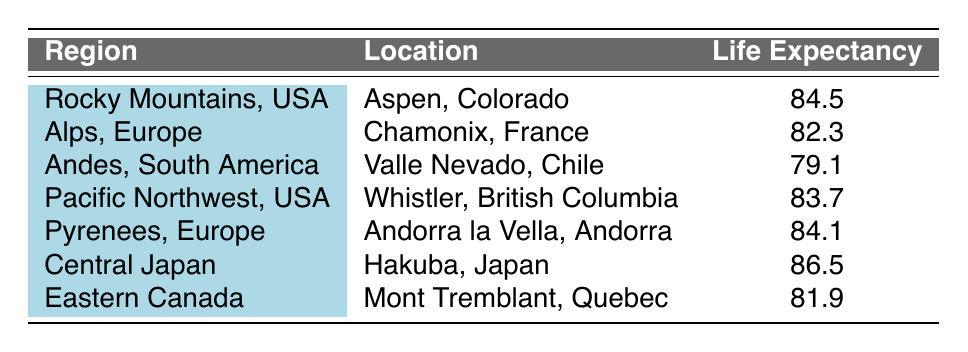What is the life expectancy in the Rocky Mountains, USA? Referring directly to the table, the life expectancy for the region "Rocky Mountains, USA," which is identified specifically with the location "Aspen, Colorado," is 84.5 years.
Answer: 84.5 Which location has the highest average life expectancy? Looking through the table, "Hakuba, Japan" under the region "Central Japan" has the highest value of average life expectancy at 86.5 years compared to all other listed locations.
Answer: Hakuba, Japan (86.5) What is the average life expectancy of locations in the Alps, Europe, and the Pyrenees, Europe combined? The average life expectancy for the Alps (Chamonix, France) is 82.3 and for the Pyrenees (Andorra la Vella, Andorra) is 84.1. To find the combined average, we sum these two values (82.3 + 84.1 = 166.4) and then divide by 2. Therefore, 166.4 / 2 = 83.2.
Answer: 83.2 Is the life expectancy in Valle Nevado, Chile higher than that in Mont Tremblant, Quebec? The life expectancy in Valle Nevado, Chile is 79.1, whereas Mont Tremblant, Quebec has a life expectancy of 81.9. Since 79.1 is less than 81.9, the statement is false.
Answer: No How does the life expectancy in Whistler, British Columbia compare to that in Chamonix, France? Whistler, British Columbia has a life expectancy of 83.7, whereas Chamonix, France has a life expectancy of 82.3. Since 83.7 is greater than 82.3, it is evident that Whistler has a higher life expectancy.
Answer: Whistler is higher What is the difference in life expectancy between the location with the highest and the lowest values? The location with the highest life expectancy is Hakuba, Japan at 86.5 years, and the lowest is Valle Nevado, Chile at 79.1 years. To find the difference, we subtract the lowest from the highest: 86.5 - 79.1 = 7.4 years.
Answer: 7.4 Is the average life expectancy in the Rocky Mountains, USA greater than that in Eastern Canada? The life expectancy in the Rocky Mountains, USA is 84.5, while in Eastern Canada it is 81.9. Since 84.5 is indeed greater than 81.9, the answer is true.
Answer: Yes What is the overall average life expectancy of all the locations listed in the table? To find the overall average, we first sum all the life expectancies: 84.5 (Rocky Mountains) + 82.3 (Alps) + 79.1 (Andes) + 83.7 (Pacific Northwest) + 84.1 (Pyrenees) + 86.5 (Central Japan) + 81.9 (Eastern Canada) = 500.1. There are 7 locations, so we divide 500.1 by 7, resulting in approximately 71.43.
Answer: 71.43 